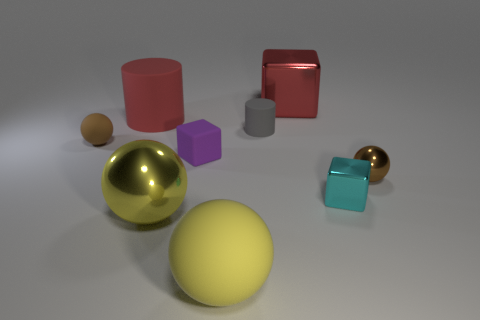Subtract all metal blocks. How many blocks are left? 1 Subtract all green blocks. How many brown spheres are left? 2 Subtract 1 cubes. How many cubes are left? 2 Subtract all purple cubes. How many cubes are left? 2 Add 1 tiny gray matte cylinders. How many objects exist? 10 Subtract all spheres. How many objects are left? 5 Subtract all green balls. Subtract all gray cylinders. How many balls are left? 4 Subtract all tiny brown metallic things. Subtract all yellow rubber spheres. How many objects are left? 7 Add 7 tiny matte cylinders. How many tiny matte cylinders are left? 8 Add 3 gray objects. How many gray objects exist? 4 